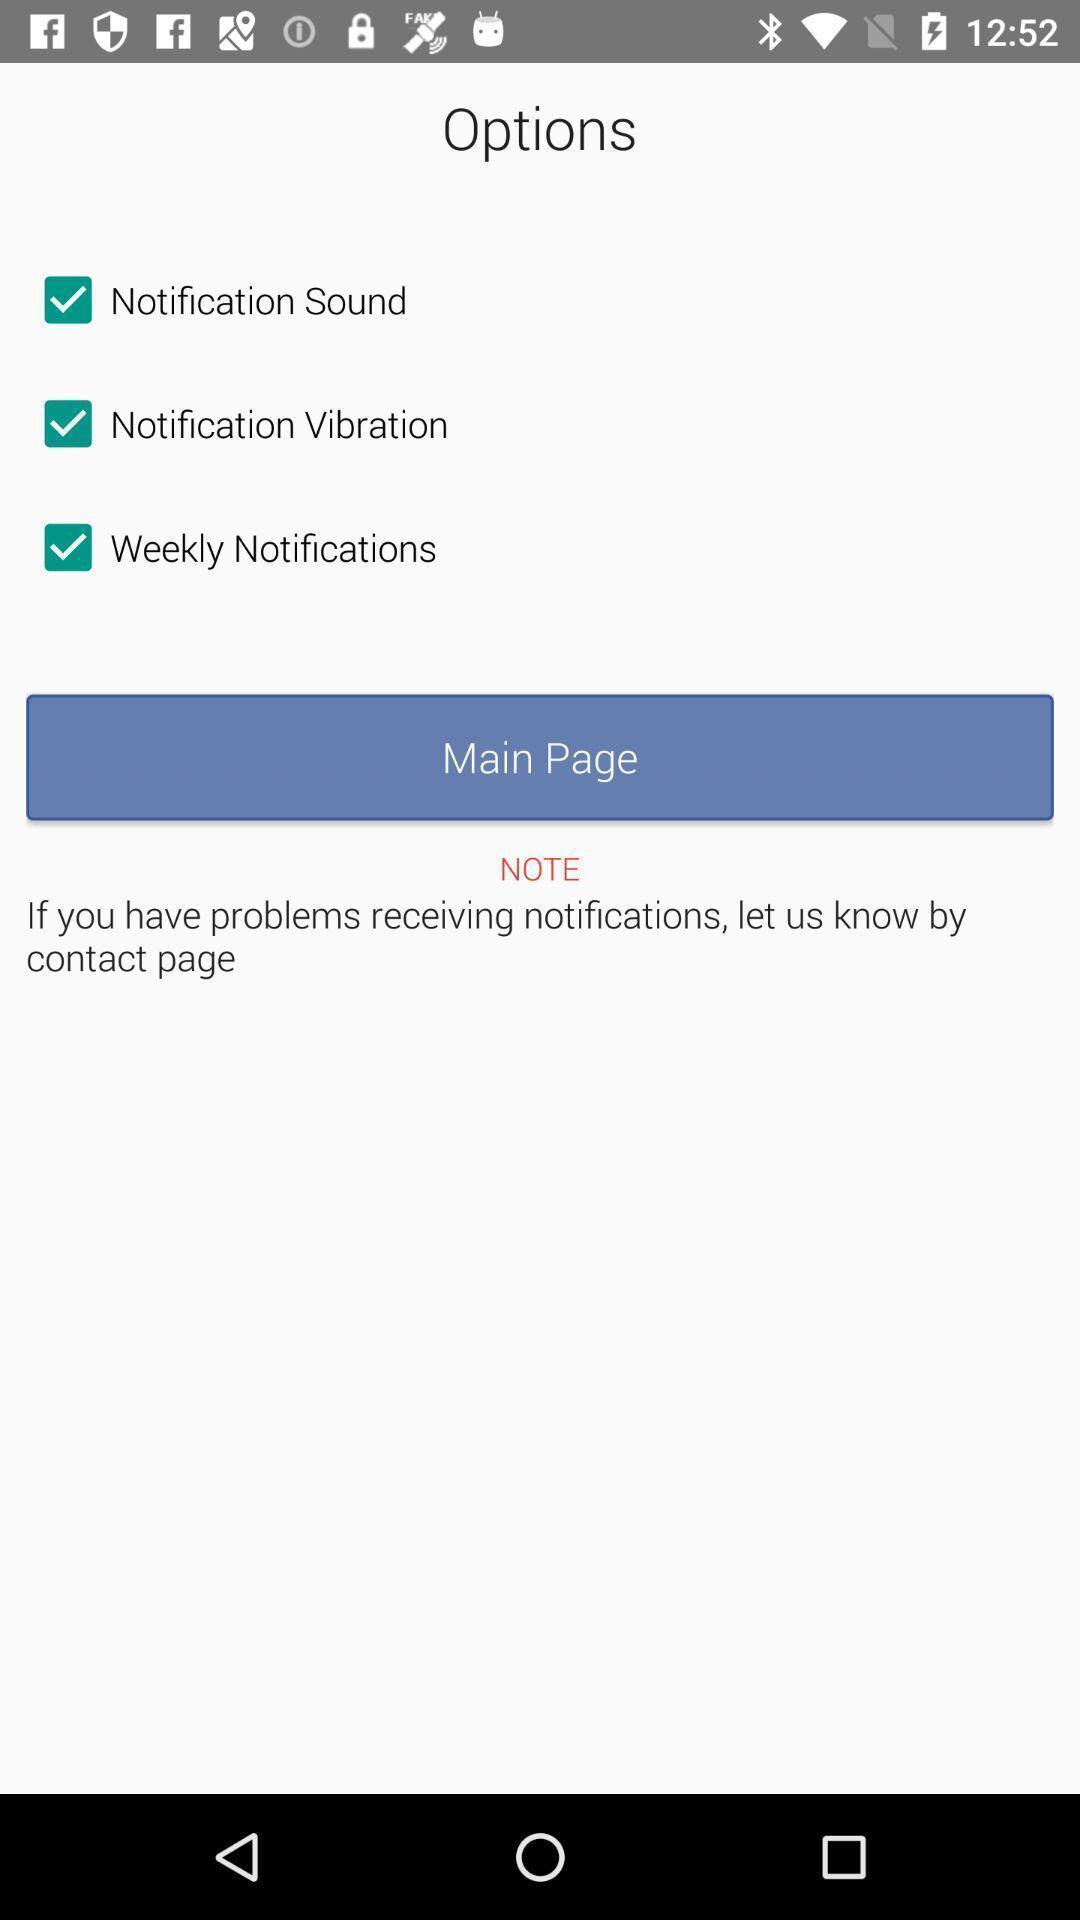Please provide a description for this image. Page with multiple options for sound settings. 